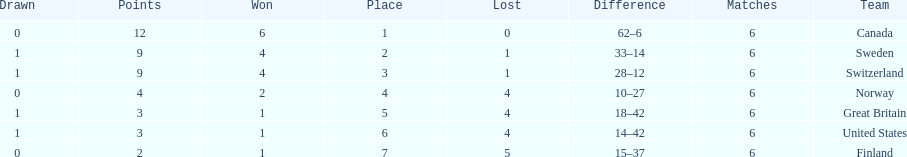Which country finished below the united states? Finland. 